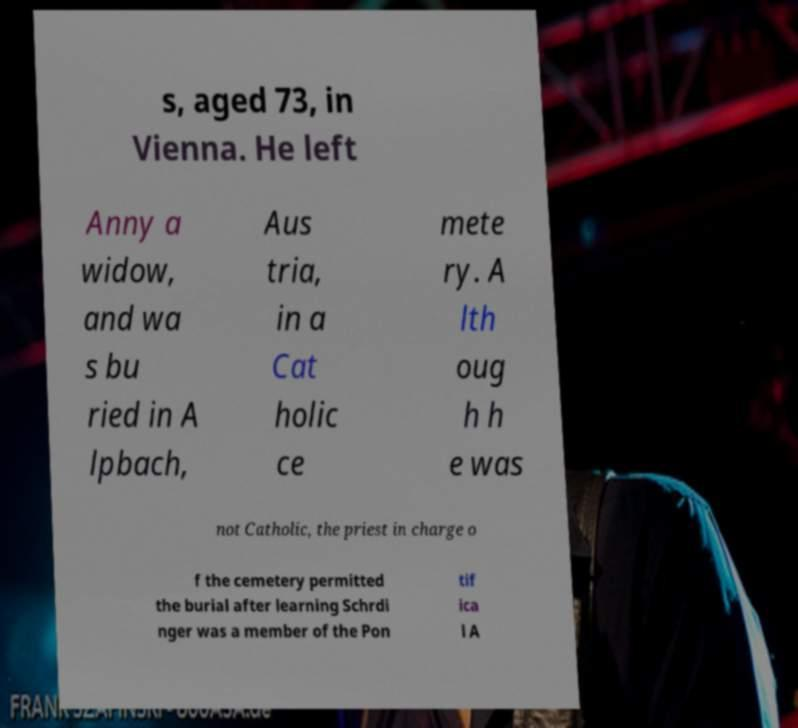I need the written content from this picture converted into text. Can you do that? s, aged 73, in Vienna. He left Anny a widow, and wa s bu ried in A lpbach, Aus tria, in a Cat holic ce mete ry. A lth oug h h e was not Catholic, the priest in charge o f the cemetery permitted the burial after learning Schrdi nger was a member of the Pon tif ica l A 